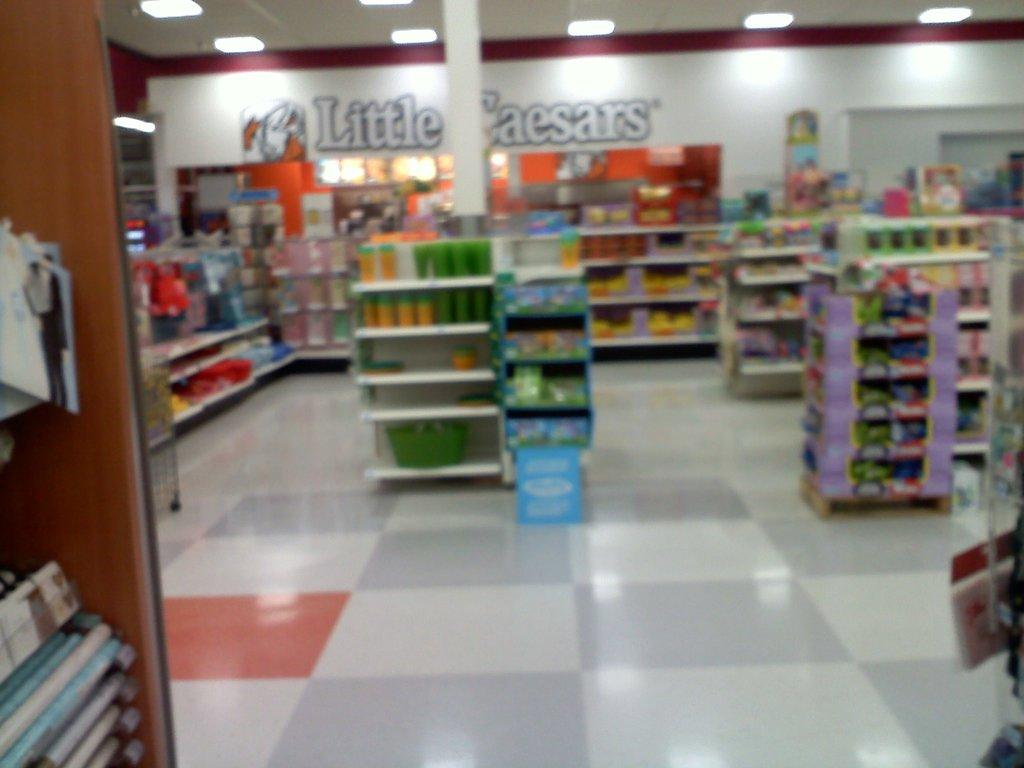<image>
Relay a brief, clear account of the picture shown. A gas station that has Little Caesars written on the back wall. 